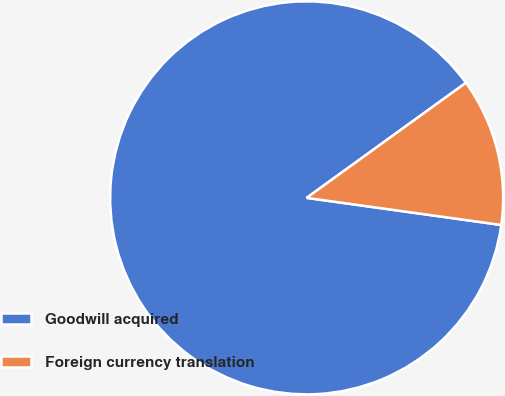<chart> <loc_0><loc_0><loc_500><loc_500><pie_chart><fcel>Goodwill acquired<fcel>Foreign currency translation<nl><fcel>87.84%<fcel>12.16%<nl></chart> 